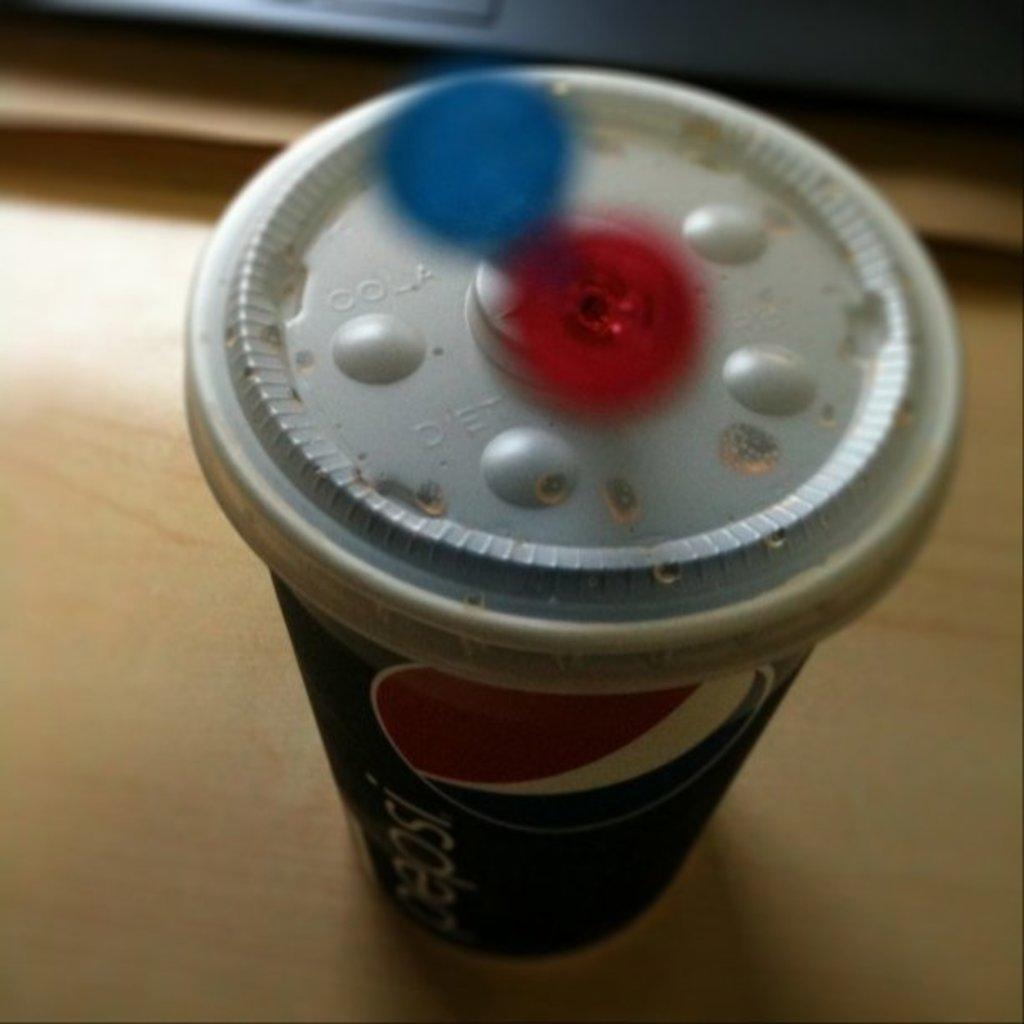Provide a one-sentence caption for the provided image. Pepsi soda on top of a wooden table. 